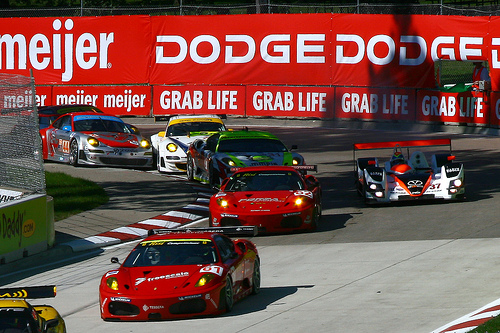<image>
Is there a car to the left of the car? Yes. From this viewpoint, the car is positioned to the left side relative to the car. 